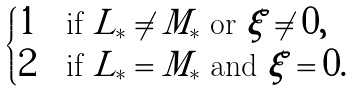<formula> <loc_0><loc_0><loc_500><loc_500>\begin{cases} 1 & \text {if $L_{*} \neq M_{*}$ or $\xi \neq 0,$} \\ 2 & \text {if $L_{*} = M_{*}$ and $\xi = 0.$} \end{cases}</formula> 